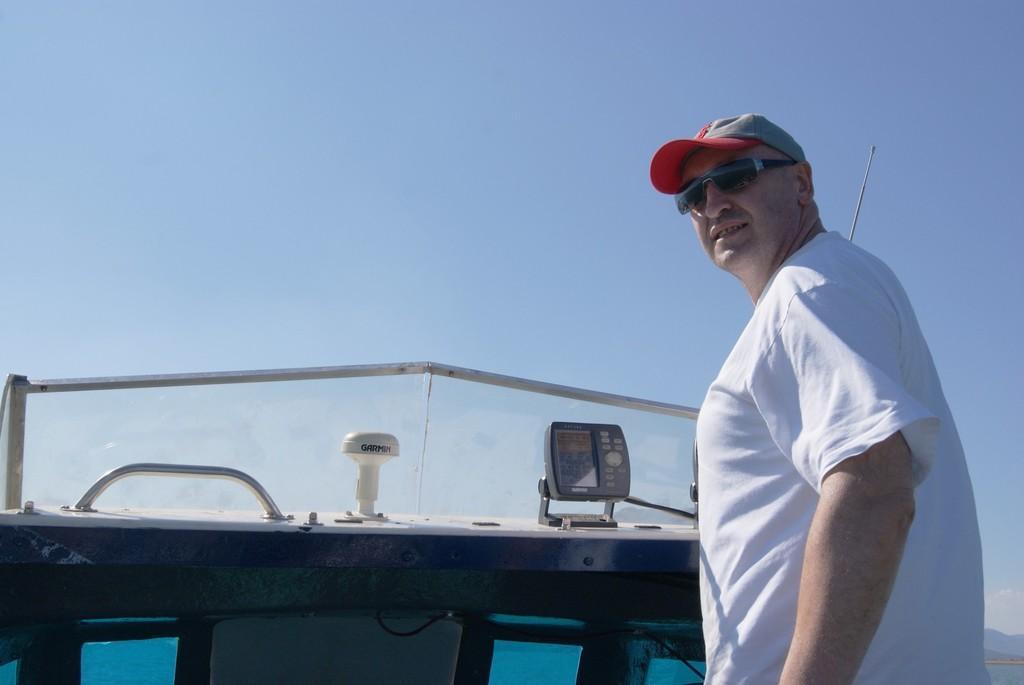Could you give a brief overview of what you see in this image? In the picture we can see a man standing in the boat and he is in a white T-shirt and a cap and in front of him we can see a gear on the boat and in front of it we can see the windshield and from it we can see the sky. 